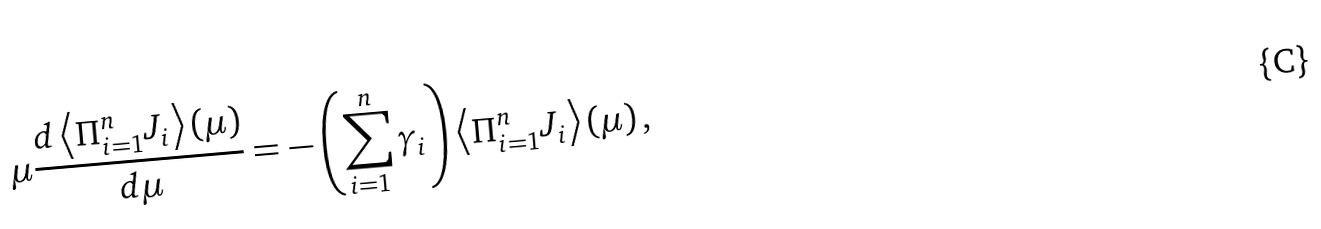<formula> <loc_0><loc_0><loc_500><loc_500>\mu \frac { d \left \langle \Pi _ { i = 1 } ^ { n } J _ { i } \right \rangle ( \mu ) } { d \mu } = - \left ( \sum _ { i = 1 } ^ { n } \gamma _ { i } \right ) \left \langle \Pi _ { i = 1 } ^ { n } J _ { i } \right \rangle ( \mu ) \, ,</formula> 